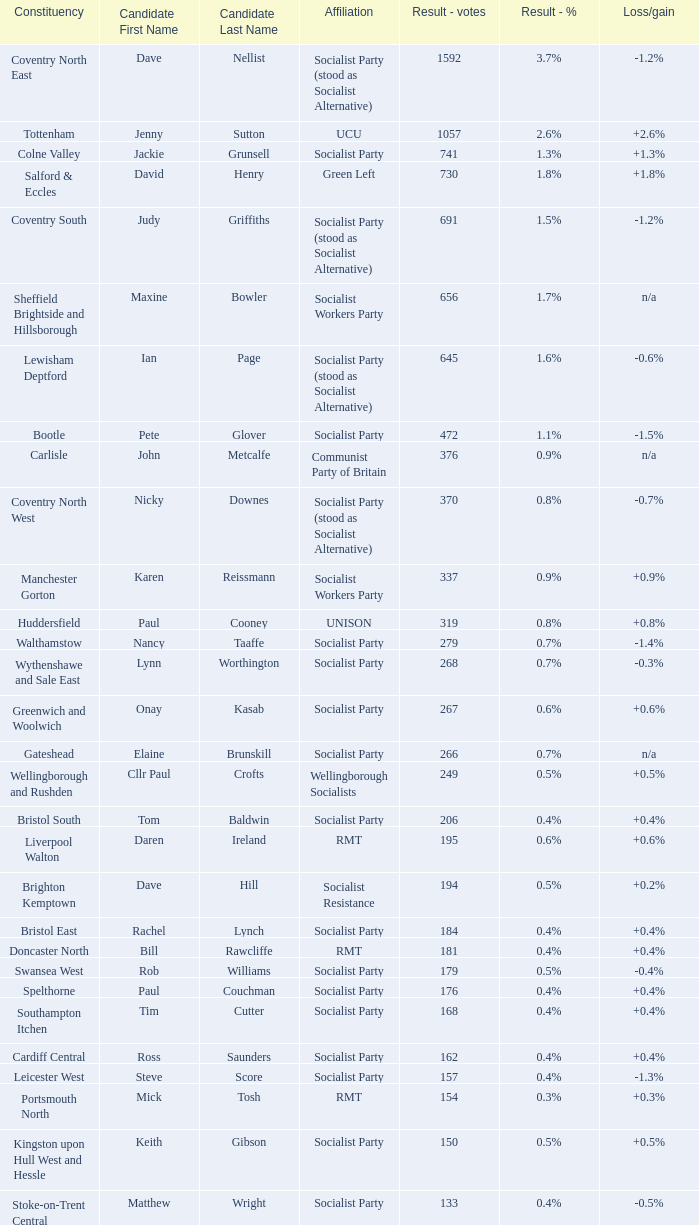How many values for constituency for the vote result of 162? 1.0. 